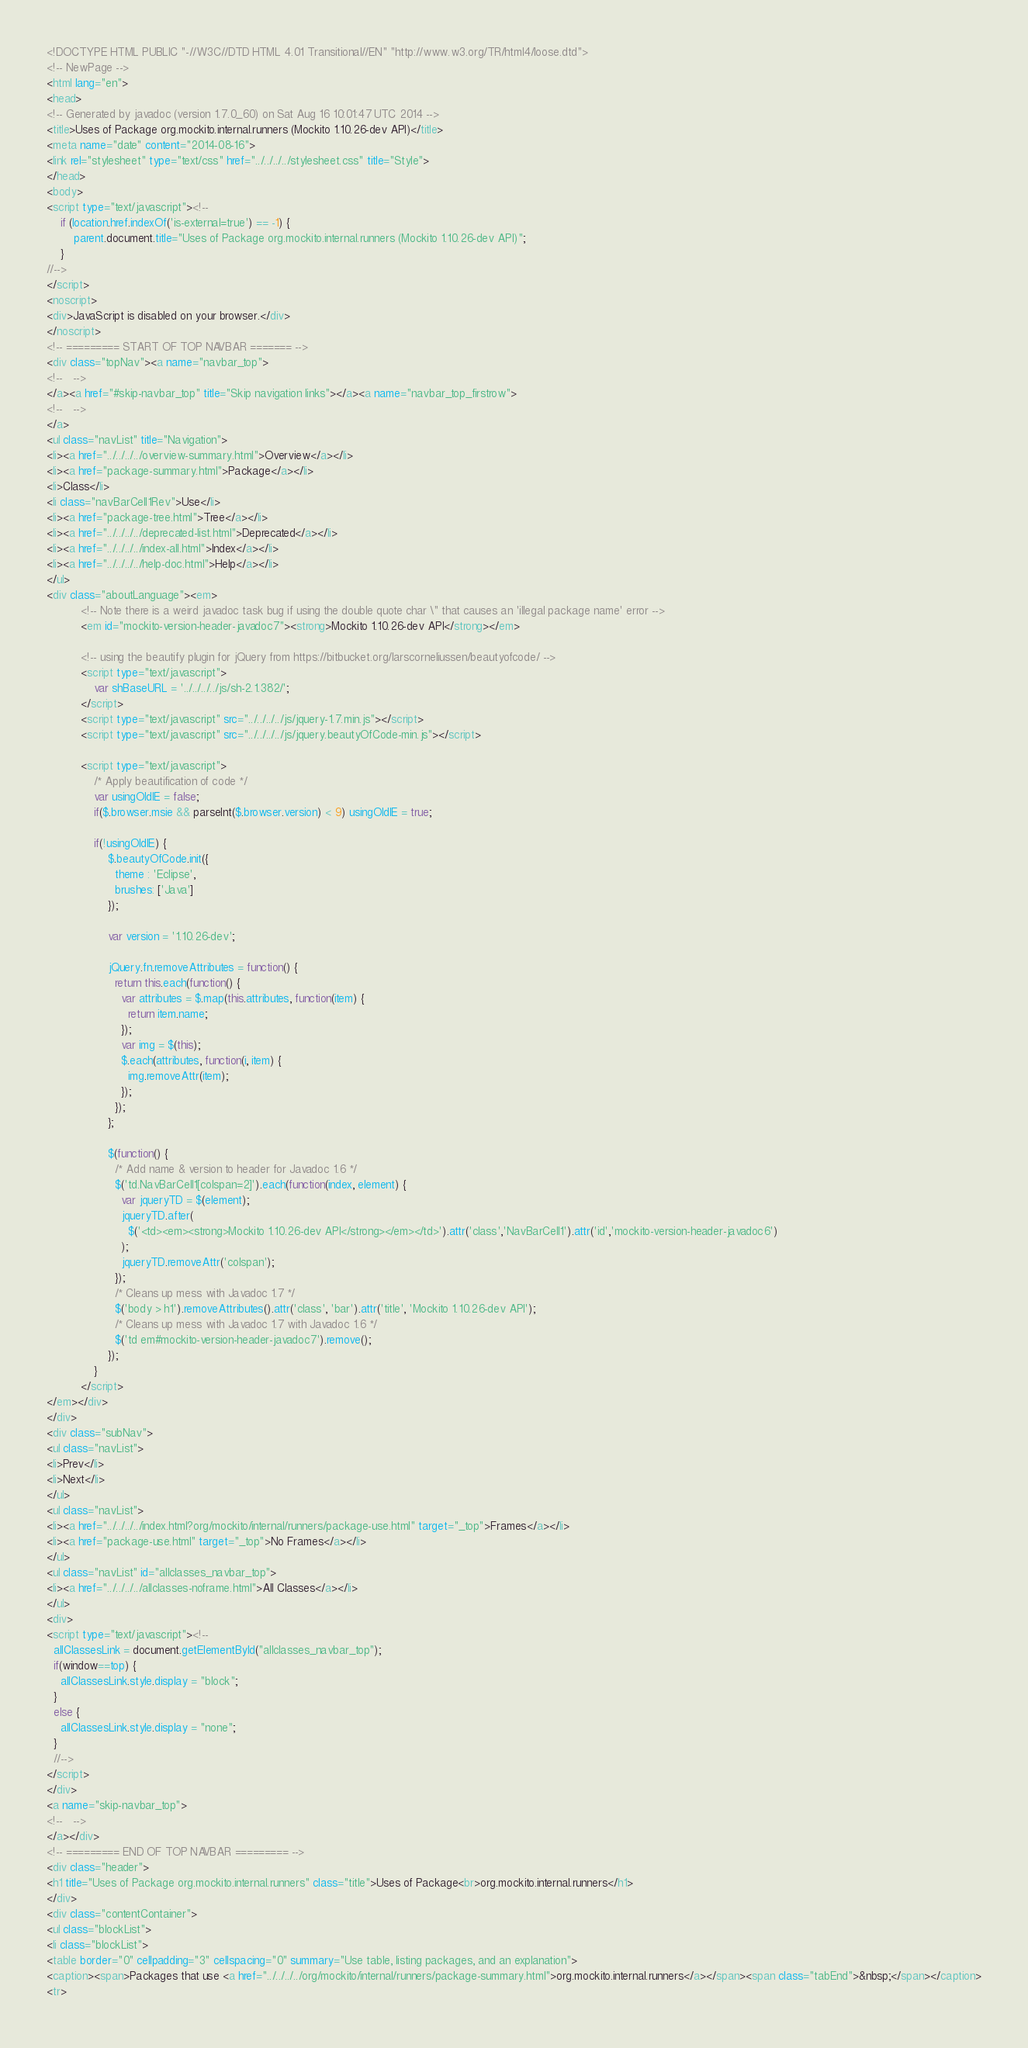<code> <loc_0><loc_0><loc_500><loc_500><_HTML_><!DOCTYPE HTML PUBLIC "-//W3C//DTD HTML 4.01 Transitional//EN" "http://www.w3.org/TR/html4/loose.dtd">
<!-- NewPage -->
<html lang="en">
<head>
<!-- Generated by javadoc (version 1.7.0_60) on Sat Aug 16 10:01:47 UTC 2014 -->
<title>Uses of Package org.mockito.internal.runners (Mockito 1.10.26-dev API)</title>
<meta name="date" content="2014-08-16">
<link rel="stylesheet" type="text/css" href="../../../../stylesheet.css" title="Style">
</head>
<body>
<script type="text/javascript"><!--
    if (location.href.indexOf('is-external=true') == -1) {
        parent.document.title="Uses of Package org.mockito.internal.runners (Mockito 1.10.26-dev API)";
    }
//-->
</script>
<noscript>
<div>JavaScript is disabled on your browser.</div>
</noscript>
<!-- ========= START OF TOP NAVBAR ======= -->
<div class="topNav"><a name="navbar_top">
<!--   -->
</a><a href="#skip-navbar_top" title="Skip navigation links"></a><a name="navbar_top_firstrow">
<!--   -->
</a>
<ul class="navList" title="Navigation">
<li><a href="../../../../overview-summary.html">Overview</a></li>
<li><a href="package-summary.html">Package</a></li>
<li>Class</li>
<li class="navBarCell1Rev">Use</li>
<li><a href="package-tree.html">Tree</a></li>
<li><a href="../../../../deprecated-list.html">Deprecated</a></li>
<li><a href="../../../../index-all.html">Index</a></li>
<li><a href="../../../../help-doc.html">Help</a></li>
</ul>
<div class="aboutLanguage"><em>
          <!-- Note there is a weird javadoc task bug if using the double quote char \" that causes an 'illegal package name' error -->
          <em id="mockito-version-header-javadoc7"><strong>Mockito 1.10.26-dev API</strong></em>

          <!-- using the beautify plugin for jQuery from https://bitbucket.org/larscorneliussen/beautyofcode/ -->
          <script type="text/javascript">
              var shBaseURL = '../../../../js/sh-2.1.382/';
          </script>
          <script type="text/javascript" src="../../../../js/jquery-1.7.min.js"></script>
          <script type="text/javascript" src="../../../../js/jquery.beautyOfCode-min.js"></script>

          <script type="text/javascript">
              /* Apply beautification of code */
              var usingOldIE = false;
              if($.browser.msie && parseInt($.browser.version) < 9) usingOldIE = true;

              if(!usingOldIE) {
                  $.beautyOfCode.init({
                    theme : 'Eclipse',
                    brushes: ['Java']
                  });

                  var version = '1.10.26-dev';

                  jQuery.fn.removeAttributes = function() {
                    return this.each(function() {
                      var attributes = $.map(this.attributes, function(item) {
                        return item.name;
                      });
                      var img = $(this);
                      $.each(attributes, function(i, item) {
                        img.removeAttr(item);
                      });
                    });
                  };

                  $(function() {
                    /* Add name & version to header for Javadoc 1.6 */
                    $('td.NavBarCell1[colspan=2]').each(function(index, element) {
                      var jqueryTD = $(element);
                      jqueryTD.after(
                        $('<td><em><strong>Mockito 1.10.26-dev API</strong></em></td>').attr('class','NavBarCell1').attr('id','mockito-version-header-javadoc6')
                      );
                      jqueryTD.removeAttr('colspan');
                    });
                    /* Cleans up mess with Javadoc 1.7 */
                    $('body > h1').removeAttributes().attr('class', 'bar').attr('title', 'Mockito 1.10.26-dev API');
                    /* Cleans up mess with Javadoc 1.7 with Javadoc 1.6 */
                    $('td em#mockito-version-header-javadoc7').remove();
                  });
              }
          </script>
</em></div>
</div>
<div class="subNav">
<ul class="navList">
<li>Prev</li>
<li>Next</li>
</ul>
<ul class="navList">
<li><a href="../../../../index.html?org/mockito/internal/runners/package-use.html" target="_top">Frames</a></li>
<li><a href="package-use.html" target="_top">No Frames</a></li>
</ul>
<ul class="navList" id="allclasses_navbar_top">
<li><a href="../../../../allclasses-noframe.html">All Classes</a></li>
</ul>
<div>
<script type="text/javascript"><!--
  allClassesLink = document.getElementById("allclasses_navbar_top");
  if(window==top) {
    allClassesLink.style.display = "block";
  }
  else {
    allClassesLink.style.display = "none";
  }
  //-->
</script>
</div>
<a name="skip-navbar_top">
<!--   -->
</a></div>
<!-- ========= END OF TOP NAVBAR ========= -->
<div class="header">
<h1 title="Uses of Package org.mockito.internal.runners" class="title">Uses of Package<br>org.mockito.internal.runners</h1>
</div>
<div class="contentContainer">
<ul class="blockList">
<li class="blockList">
<table border="0" cellpadding="3" cellspacing="0" summary="Use table, listing packages, and an explanation">
<caption><span>Packages that use <a href="../../../../org/mockito/internal/runners/package-summary.html">org.mockito.internal.runners</a></span><span class="tabEnd">&nbsp;</span></caption>
<tr></code> 